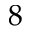<formula> <loc_0><loc_0><loc_500><loc_500>8</formula> 